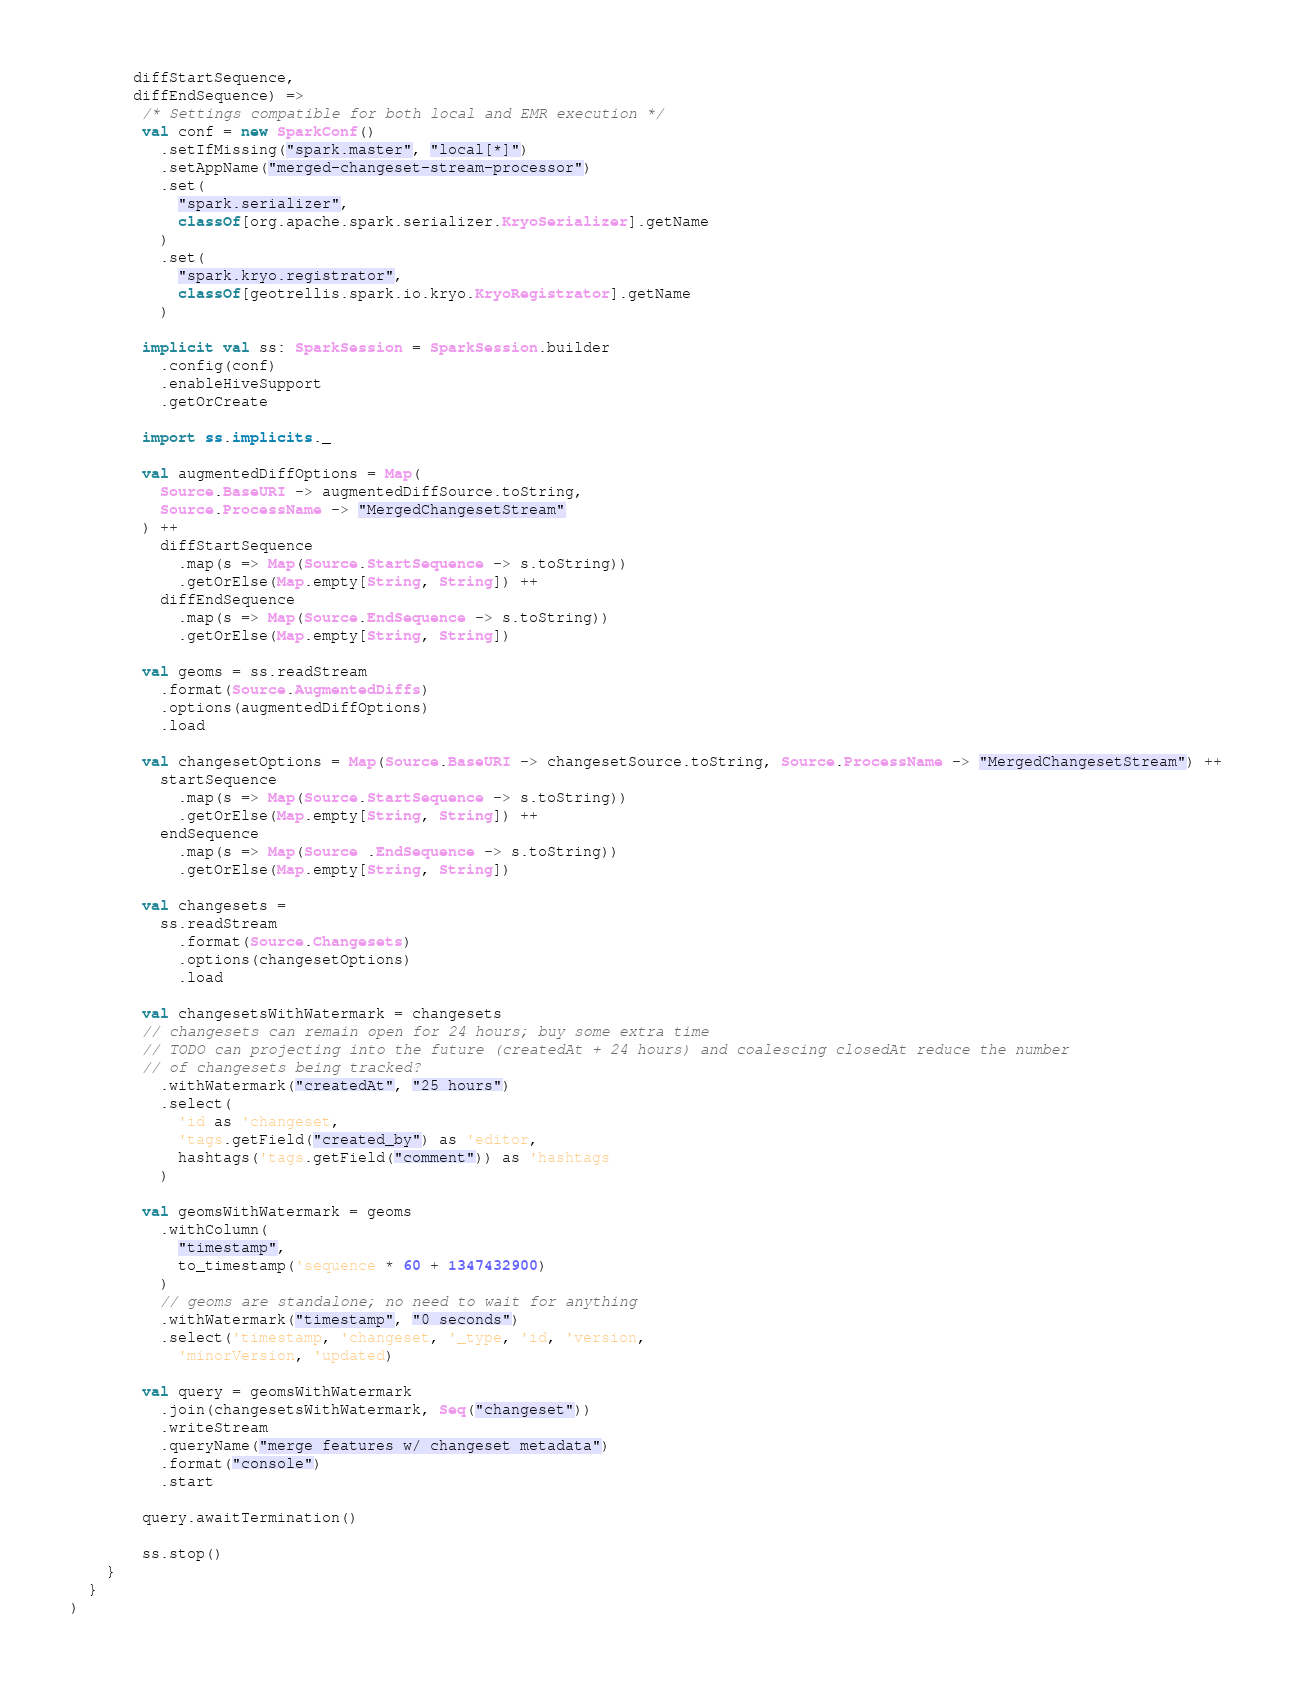Convert code to text. <code><loc_0><loc_0><loc_500><loc_500><_Scala_>       diffStartSequence,
       diffEndSequence) =>
        /* Settings compatible for both local and EMR execution */
        val conf = new SparkConf()
          .setIfMissing("spark.master", "local[*]")
          .setAppName("merged-changeset-stream-processor")
          .set(
            "spark.serializer",
            classOf[org.apache.spark.serializer.KryoSerializer].getName
          )
          .set(
            "spark.kryo.registrator",
            classOf[geotrellis.spark.io.kryo.KryoRegistrator].getName
          )

        implicit val ss: SparkSession = SparkSession.builder
          .config(conf)
          .enableHiveSupport
          .getOrCreate

        import ss.implicits._

        val augmentedDiffOptions = Map(
          Source.BaseURI -> augmentedDiffSource.toString,
          Source.ProcessName -> "MergedChangesetStream"
        ) ++
          diffStartSequence
            .map(s => Map(Source.StartSequence -> s.toString))
            .getOrElse(Map.empty[String, String]) ++
          diffEndSequence
            .map(s => Map(Source.EndSequence -> s.toString))
            .getOrElse(Map.empty[String, String])

        val geoms = ss.readStream
          .format(Source.AugmentedDiffs)
          .options(augmentedDiffOptions)
          .load

        val changesetOptions = Map(Source.BaseURI -> changesetSource.toString, Source.ProcessName -> "MergedChangesetStream") ++
          startSequence
            .map(s => Map(Source.StartSequence -> s.toString))
            .getOrElse(Map.empty[String, String]) ++
          endSequence
            .map(s => Map(Source .EndSequence -> s.toString))
            .getOrElse(Map.empty[String, String])

        val changesets =
          ss.readStream
            .format(Source.Changesets)
            .options(changesetOptions)
            .load

        val changesetsWithWatermark = changesets
        // changesets can remain open for 24 hours; buy some extra time
        // TODO can projecting into the future (createdAt + 24 hours) and coalescing closedAt reduce the number
        // of changesets being tracked?
          .withWatermark("createdAt", "25 hours")
          .select(
            'id as 'changeset,
            'tags.getField("created_by") as 'editor,
            hashtags('tags.getField("comment")) as 'hashtags
          )

        val geomsWithWatermark = geoms
          .withColumn(
            "timestamp",
            to_timestamp('sequence * 60 + 1347432900)
          )
          // geoms are standalone; no need to wait for anything
          .withWatermark("timestamp", "0 seconds")
          .select('timestamp, 'changeset, '_type, 'id, 'version,
            'minorVersion, 'updated)

        val query = geomsWithWatermark
          .join(changesetsWithWatermark, Seq("changeset"))
          .writeStream
          .queryName("merge features w/ changeset metadata")
          .format("console")
          .start

        query.awaitTermination()

        ss.stop()
    }
  }
)
</code> 